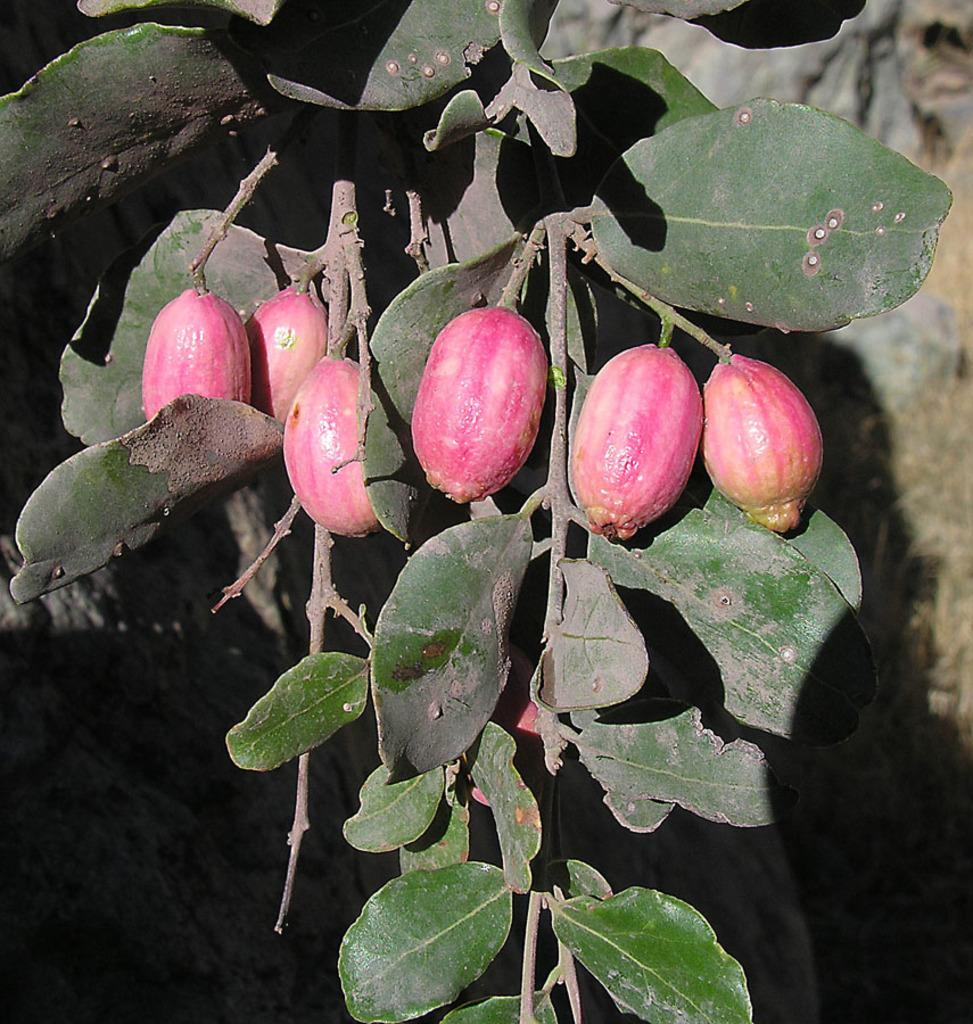What is present in the image that is related to a tree? There is a tree branch in the image. What can be found on the tree branch? The tree branch has fruits on it. Are there any horses in the image? No, there are no horses present in the image. What type of pleasure can be derived from the fruits on the tree branch? The image does not convey any information about the pleasure derived from the fruits; it only shows the presence of fruits on the tree branch. 